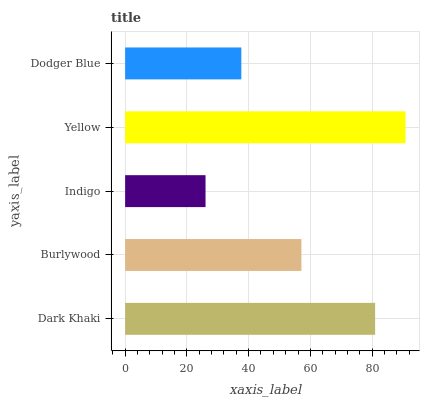Is Indigo the minimum?
Answer yes or no. Yes. Is Yellow the maximum?
Answer yes or no. Yes. Is Burlywood the minimum?
Answer yes or no. No. Is Burlywood the maximum?
Answer yes or no. No. Is Dark Khaki greater than Burlywood?
Answer yes or no. Yes. Is Burlywood less than Dark Khaki?
Answer yes or no. Yes. Is Burlywood greater than Dark Khaki?
Answer yes or no. No. Is Dark Khaki less than Burlywood?
Answer yes or no. No. Is Burlywood the high median?
Answer yes or no. Yes. Is Burlywood the low median?
Answer yes or no. Yes. Is Yellow the high median?
Answer yes or no. No. Is Yellow the low median?
Answer yes or no. No. 